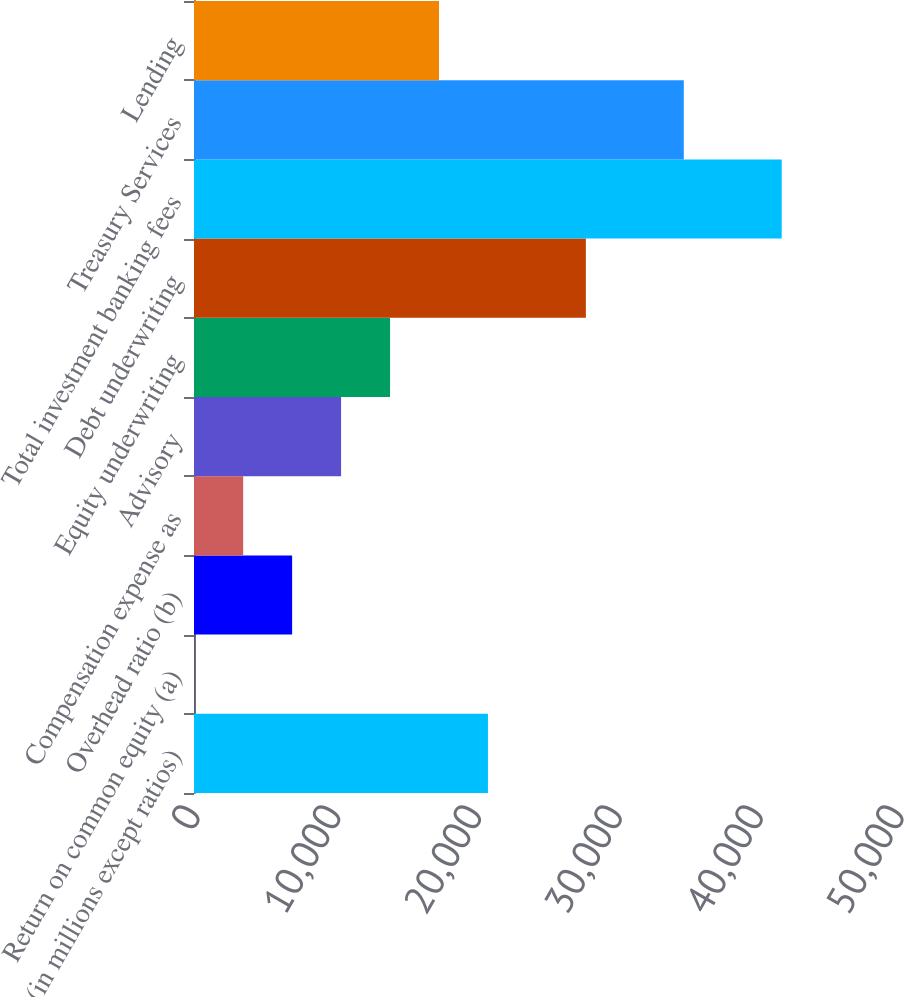Convert chart to OTSL. <chart><loc_0><loc_0><loc_500><loc_500><bar_chart><fcel>(in millions except ratios)<fcel>Return on common equity (a)<fcel>Overhead ratio (b)<fcel>Compensation expense as<fcel>Advisory<fcel>Equity underwriting<fcel>Debt underwriting<fcel>Total investment banking fees<fcel>Treasury Services<fcel>Lending<nl><fcel>20877.6<fcel>15<fcel>6969.2<fcel>3492.1<fcel>10446.3<fcel>13923.4<fcel>27831.8<fcel>41740.2<fcel>34786<fcel>17400.5<nl></chart> 